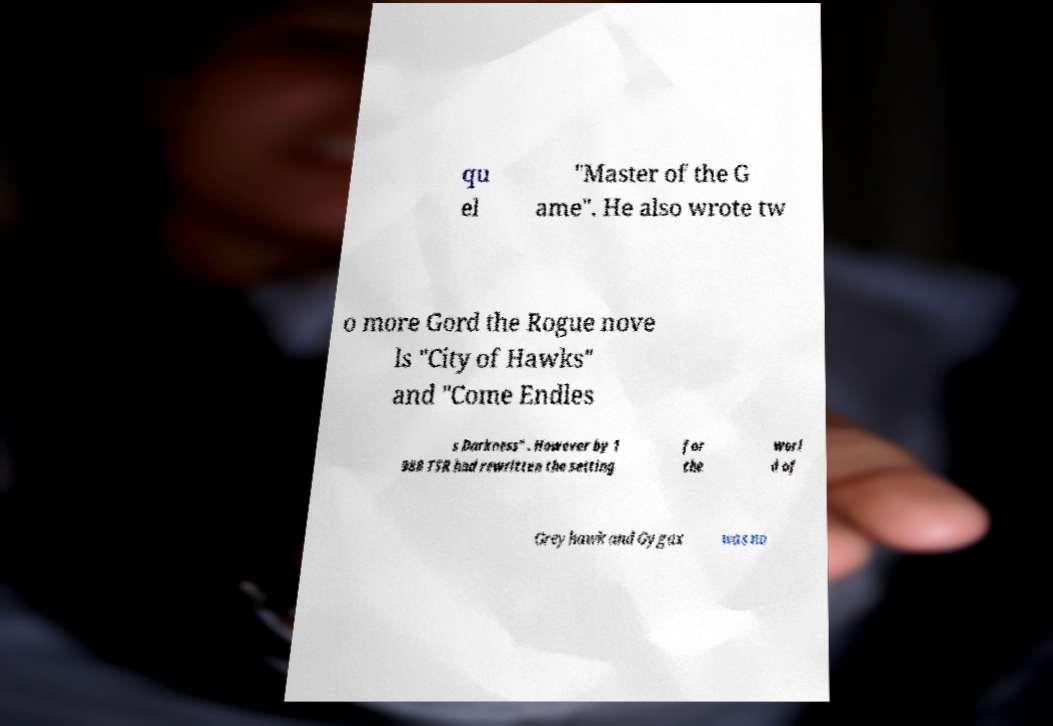What messages or text are displayed in this image? I need them in a readable, typed format. qu el "Master of the G ame". He also wrote tw o more Gord the Rogue nove ls "City of Hawks" and "Come Endles s Darkness" . However by 1 988 TSR had rewritten the setting for the worl d of Greyhawk and Gygax was no 